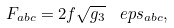Convert formula to latex. <formula><loc_0><loc_0><loc_500><loc_500>F _ { a b c } = 2 f \sqrt { g _ { 3 } } \, \ e p s _ { a b c } ,</formula> 